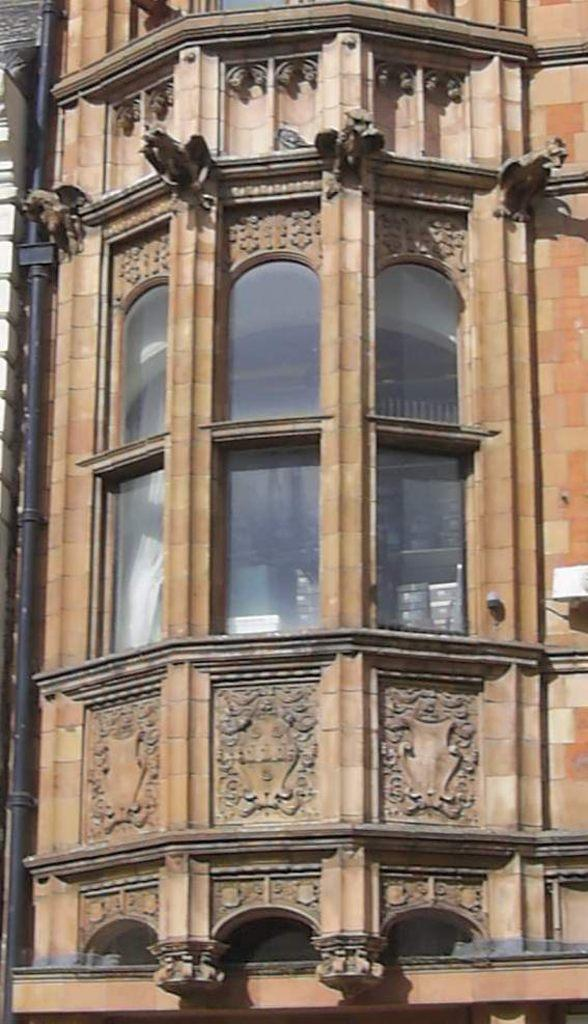What type of structure is present in the image? There is a building in the image. What feature can be observed on the building? The building has glass windows. Are there any other types of windows on the building? Yes, the building has windows in addition to the glass ones. What else can be seen in the image besides the building? There is a pole and other objects in the image. What type of prose is being recited by the building in the image? There is no indication in the image that the building is reciting any prose. 